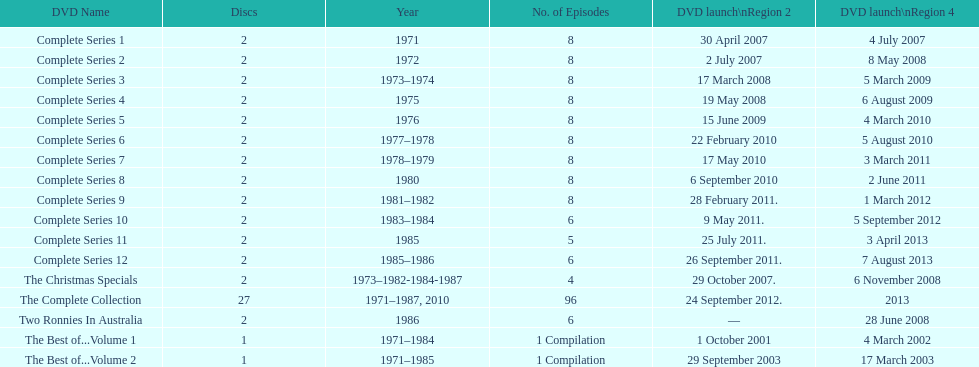Dvd shorter than 5 episodes The Christmas Specials. 